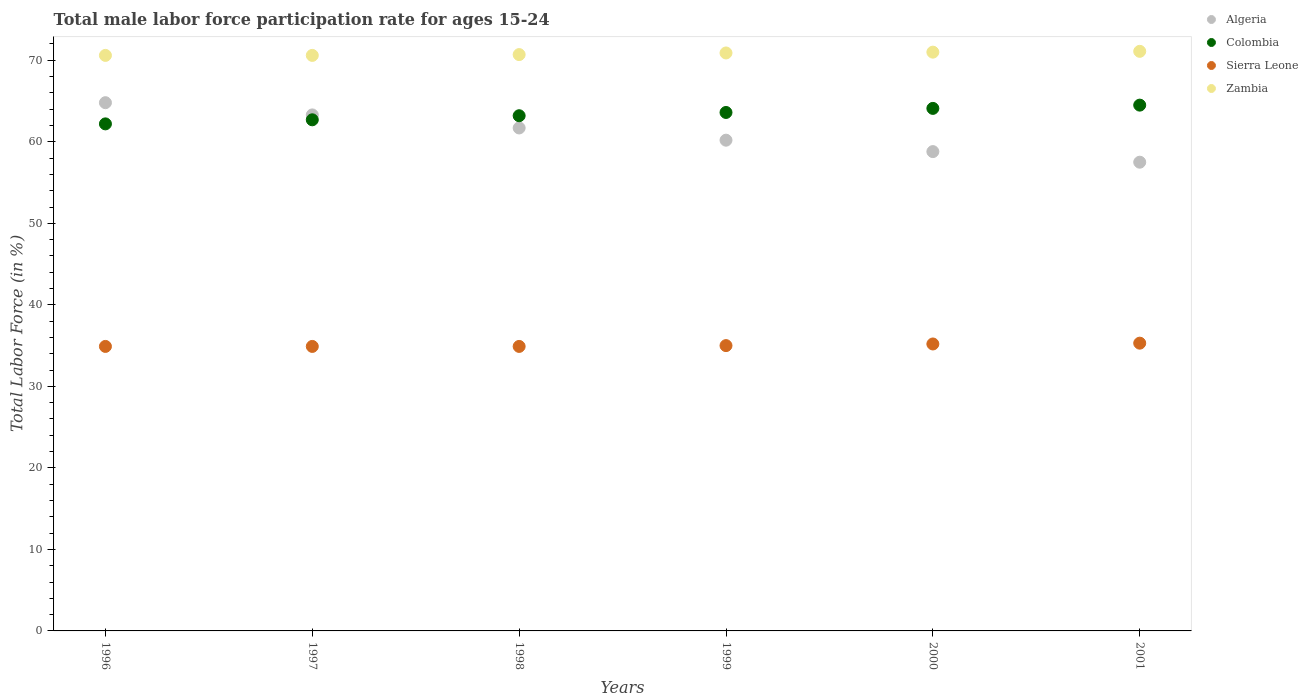How many different coloured dotlines are there?
Ensure brevity in your answer.  4. Is the number of dotlines equal to the number of legend labels?
Provide a short and direct response. Yes. What is the male labor force participation rate in Sierra Leone in 1999?
Ensure brevity in your answer.  35. Across all years, what is the maximum male labor force participation rate in Sierra Leone?
Offer a terse response. 35.3. Across all years, what is the minimum male labor force participation rate in Sierra Leone?
Your answer should be very brief. 34.9. In which year was the male labor force participation rate in Sierra Leone minimum?
Your answer should be compact. 1996. What is the total male labor force participation rate in Colombia in the graph?
Your answer should be very brief. 380.3. What is the difference between the male labor force participation rate in Zambia in 1998 and that in 1999?
Provide a short and direct response. -0.2. What is the difference between the male labor force participation rate in Colombia in 2000 and the male labor force participation rate in Algeria in 1996?
Provide a short and direct response. -0.7. What is the average male labor force participation rate in Sierra Leone per year?
Offer a very short reply. 35.03. In the year 2000, what is the difference between the male labor force participation rate in Colombia and male labor force participation rate in Zambia?
Make the answer very short. -6.9. In how many years, is the male labor force participation rate in Algeria greater than 16 %?
Offer a very short reply. 6. What is the ratio of the male labor force participation rate in Colombia in 1999 to that in 2001?
Offer a terse response. 0.99. Is the male labor force participation rate in Zambia in 1998 less than that in 2000?
Provide a short and direct response. Yes. What is the difference between the highest and the second highest male labor force participation rate in Algeria?
Your answer should be very brief. 1.5. What is the difference between the highest and the lowest male labor force participation rate in Sierra Leone?
Your answer should be compact. 0.4. In how many years, is the male labor force participation rate in Zambia greater than the average male labor force participation rate in Zambia taken over all years?
Offer a terse response. 3. Is the sum of the male labor force participation rate in Algeria in 1996 and 1997 greater than the maximum male labor force participation rate in Colombia across all years?
Your answer should be very brief. Yes. Is it the case that in every year, the sum of the male labor force participation rate in Sierra Leone and male labor force participation rate in Zambia  is greater than the sum of male labor force participation rate in Colombia and male labor force participation rate in Algeria?
Give a very brief answer. No. Is the male labor force participation rate in Colombia strictly greater than the male labor force participation rate in Zambia over the years?
Make the answer very short. No. Is the male labor force participation rate in Colombia strictly less than the male labor force participation rate in Zambia over the years?
Provide a succinct answer. Yes. How many years are there in the graph?
Give a very brief answer. 6. What is the difference between two consecutive major ticks on the Y-axis?
Make the answer very short. 10. Does the graph contain grids?
Provide a succinct answer. No. How many legend labels are there?
Make the answer very short. 4. How are the legend labels stacked?
Provide a short and direct response. Vertical. What is the title of the graph?
Give a very brief answer. Total male labor force participation rate for ages 15-24. What is the label or title of the X-axis?
Offer a terse response. Years. What is the Total Labor Force (in %) of Algeria in 1996?
Make the answer very short. 64.8. What is the Total Labor Force (in %) of Colombia in 1996?
Your answer should be very brief. 62.2. What is the Total Labor Force (in %) of Sierra Leone in 1996?
Provide a short and direct response. 34.9. What is the Total Labor Force (in %) in Zambia in 1996?
Keep it short and to the point. 70.6. What is the Total Labor Force (in %) of Algeria in 1997?
Give a very brief answer. 63.3. What is the Total Labor Force (in %) in Colombia in 1997?
Offer a very short reply. 62.7. What is the Total Labor Force (in %) of Sierra Leone in 1997?
Ensure brevity in your answer.  34.9. What is the Total Labor Force (in %) of Zambia in 1997?
Provide a succinct answer. 70.6. What is the Total Labor Force (in %) in Algeria in 1998?
Offer a very short reply. 61.7. What is the Total Labor Force (in %) of Colombia in 1998?
Give a very brief answer. 63.2. What is the Total Labor Force (in %) of Sierra Leone in 1998?
Offer a very short reply. 34.9. What is the Total Labor Force (in %) in Zambia in 1998?
Provide a succinct answer. 70.7. What is the Total Labor Force (in %) in Algeria in 1999?
Make the answer very short. 60.2. What is the Total Labor Force (in %) in Colombia in 1999?
Your answer should be compact. 63.6. What is the Total Labor Force (in %) in Zambia in 1999?
Give a very brief answer. 70.9. What is the Total Labor Force (in %) of Algeria in 2000?
Offer a very short reply. 58.8. What is the Total Labor Force (in %) of Colombia in 2000?
Offer a terse response. 64.1. What is the Total Labor Force (in %) in Sierra Leone in 2000?
Your answer should be compact. 35.2. What is the Total Labor Force (in %) of Algeria in 2001?
Offer a very short reply. 57.5. What is the Total Labor Force (in %) in Colombia in 2001?
Provide a succinct answer. 64.5. What is the Total Labor Force (in %) in Sierra Leone in 2001?
Provide a short and direct response. 35.3. What is the Total Labor Force (in %) of Zambia in 2001?
Give a very brief answer. 71.1. Across all years, what is the maximum Total Labor Force (in %) of Algeria?
Provide a short and direct response. 64.8. Across all years, what is the maximum Total Labor Force (in %) of Colombia?
Keep it short and to the point. 64.5. Across all years, what is the maximum Total Labor Force (in %) in Sierra Leone?
Offer a terse response. 35.3. Across all years, what is the maximum Total Labor Force (in %) in Zambia?
Ensure brevity in your answer.  71.1. Across all years, what is the minimum Total Labor Force (in %) in Algeria?
Your response must be concise. 57.5. Across all years, what is the minimum Total Labor Force (in %) of Colombia?
Offer a very short reply. 62.2. Across all years, what is the minimum Total Labor Force (in %) in Sierra Leone?
Give a very brief answer. 34.9. Across all years, what is the minimum Total Labor Force (in %) of Zambia?
Your answer should be very brief. 70.6. What is the total Total Labor Force (in %) of Algeria in the graph?
Provide a short and direct response. 366.3. What is the total Total Labor Force (in %) in Colombia in the graph?
Give a very brief answer. 380.3. What is the total Total Labor Force (in %) in Sierra Leone in the graph?
Offer a very short reply. 210.2. What is the total Total Labor Force (in %) in Zambia in the graph?
Provide a short and direct response. 424.9. What is the difference between the Total Labor Force (in %) of Algeria in 1996 and that in 1997?
Your response must be concise. 1.5. What is the difference between the Total Labor Force (in %) of Algeria in 1996 and that in 1998?
Your answer should be very brief. 3.1. What is the difference between the Total Labor Force (in %) in Sierra Leone in 1996 and that in 1998?
Offer a very short reply. 0. What is the difference between the Total Labor Force (in %) in Zambia in 1996 and that in 1998?
Your response must be concise. -0.1. What is the difference between the Total Labor Force (in %) of Algeria in 1996 and that in 1999?
Keep it short and to the point. 4.6. What is the difference between the Total Labor Force (in %) in Colombia in 1996 and that in 1999?
Make the answer very short. -1.4. What is the difference between the Total Labor Force (in %) in Sierra Leone in 1996 and that in 1999?
Give a very brief answer. -0.1. What is the difference between the Total Labor Force (in %) of Algeria in 1996 and that in 2000?
Provide a succinct answer. 6. What is the difference between the Total Labor Force (in %) of Sierra Leone in 1996 and that in 2000?
Your response must be concise. -0.3. What is the difference between the Total Labor Force (in %) of Zambia in 1996 and that in 2000?
Give a very brief answer. -0.4. What is the difference between the Total Labor Force (in %) in Algeria in 1996 and that in 2001?
Provide a succinct answer. 7.3. What is the difference between the Total Labor Force (in %) of Sierra Leone in 1996 and that in 2001?
Your answer should be compact. -0.4. What is the difference between the Total Labor Force (in %) in Zambia in 1996 and that in 2001?
Offer a terse response. -0.5. What is the difference between the Total Labor Force (in %) in Algeria in 1997 and that in 1998?
Provide a short and direct response. 1.6. What is the difference between the Total Labor Force (in %) of Zambia in 1997 and that in 1998?
Provide a short and direct response. -0.1. What is the difference between the Total Labor Force (in %) in Algeria in 1997 and that in 2000?
Ensure brevity in your answer.  4.5. What is the difference between the Total Labor Force (in %) in Colombia in 1997 and that in 2000?
Your answer should be compact. -1.4. What is the difference between the Total Labor Force (in %) of Sierra Leone in 1997 and that in 2000?
Your response must be concise. -0.3. What is the difference between the Total Labor Force (in %) in Zambia in 1997 and that in 2000?
Make the answer very short. -0.4. What is the difference between the Total Labor Force (in %) of Algeria in 1997 and that in 2001?
Give a very brief answer. 5.8. What is the difference between the Total Labor Force (in %) of Colombia in 1997 and that in 2001?
Offer a terse response. -1.8. What is the difference between the Total Labor Force (in %) of Sierra Leone in 1997 and that in 2001?
Provide a short and direct response. -0.4. What is the difference between the Total Labor Force (in %) in Zambia in 1997 and that in 2001?
Offer a very short reply. -0.5. What is the difference between the Total Labor Force (in %) of Sierra Leone in 1998 and that in 1999?
Give a very brief answer. -0.1. What is the difference between the Total Labor Force (in %) of Zambia in 1998 and that in 1999?
Offer a very short reply. -0.2. What is the difference between the Total Labor Force (in %) of Colombia in 1998 and that in 2000?
Ensure brevity in your answer.  -0.9. What is the difference between the Total Labor Force (in %) of Sierra Leone in 1998 and that in 2000?
Offer a terse response. -0.3. What is the difference between the Total Labor Force (in %) of Zambia in 1998 and that in 2001?
Provide a short and direct response. -0.4. What is the difference between the Total Labor Force (in %) of Zambia in 1999 and that in 2000?
Provide a succinct answer. -0.1. What is the difference between the Total Labor Force (in %) of Colombia in 1999 and that in 2001?
Offer a very short reply. -0.9. What is the difference between the Total Labor Force (in %) of Algeria in 2000 and that in 2001?
Offer a very short reply. 1.3. What is the difference between the Total Labor Force (in %) in Colombia in 2000 and that in 2001?
Provide a short and direct response. -0.4. What is the difference between the Total Labor Force (in %) of Sierra Leone in 2000 and that in 2001?
Provide a short and direct response. -0.1. What is the difference between the Total Labor Force (in %) of Algeria in 1996 and the Total Labor Force (in %) of Sierra Leone in 1997?
Your answer should be compact. 29.9. What is the difference between the Total Labor Force (in %) in Colombia in 1996 and the Total Labor Force (in %) in Sierra Leone in 1997?
Ensure brevity in your answer.  27.3. What is the difference between the Total Labor Force (in %) in Colombia in 1996 and the Total Labor Force (in %) in Zambia in 1997?
Offer a very short reply. -8.4. What is the difference between the Total Labor Force (in %) in Sierra Leone in 1996 and the Total Labor Force (in %) in Zambia in 1997?
Make the answer very short. -35.7. What is the difference between the Total Labor Force (in %) of Algeria in 1996 and the Total Labor Force (in %) of Sierra Leone in 1998?
Keep it short and to the point. 29.9. What is the difference between the Total Labor Force (in %) in Colombia in 1996 and the Total Labor Force (in %) in Sierra Leone in 1998?
Offer a very short reply. 27.3. What is the difference between the Total Labor Force (in %) of Sierra Leone in 1996 and the Total Labor Force (in %) of Zambia in 1998?
Keep it short and to the point. -35.8. What is the difference between the Total Labor Force (in %) in Algeria in 1996 and the Total Labor Force (in %) in Sierra Leone in 1999?
Give a very brief answer. 29.8. What is the difference between the Total Labor Force (in %) in Algeria in 1996 and the Total Labor Force (in %) in Zambia in 1999?
Your response must be concise. -6.1. What is the difference between the Total Labor Force (in %) of Colombia in 1996 and the Total Labor Force (in %) of Sierra Leone in 1999?
Offer a terse response. 27.2. What is the difference between the Total Labor Force (in %) of Colombia in 1996 and the Total Labor Force (in %) of Zambia in 1999?
Your response must be concise. -8.7. What is the difference between the Total Labor Force (in %) in Sierra Leone in 1996 and the Total Labor Force (in %) in Zambia in 1999?
Provide a short and direct response. -36. What is the difference between the Total Labor Force (in %) of Algeria in 1996 and the Total Labor Force (in %) of Colombia in 2000?
Give a very brief answer. 0.7. What is the difference between the Total Labor Force (in %) in Algeria in 1996 and the Total Labor Force (in %) in Sierra Leone in 2000?
Your answer should be very brief. 29.6. What is the difference between the Total Labor Force (in %) in Sierra Leone in 1996 and the Total Labor Force (in %) in Zambia in 2000?
Offer a very short reply. -36.1. What is the difference between the Total Labor Force (in %) of Algeria in 1996 and the Total Labor Force (in %) of Sierra Leone in 2001?
Give a very brief answer. 29.5. What is the difference between the Total Labor Force (in %) of Colombia in 1996 and the Total Labor Force (in %) of Sierra Leone in 2001?
Your response must be concise. 26.9. What is the difference between the Total Labor Force (in %) of Sierra Leone in 1996 and the Total Labor Force (in %) of Zambia in 2001?
Offer a very short reply. -36.2. What is the difference between the Total Labor Force (in %) in Algeria in 1997 and the Total Labor Force (in %) in Colombia in 1998?
Your answer should be compact. 0.1. What is the difference between the Total Labor Force (in %) in Algeria in 1997 and the Total Labor Force (in %) in Sierra Leone in 1998?
Keep it short and to the point. 28.4. What is the difference between the Total Labor Force (in %) of Algeria in 1997 and the Total Labor Force (in %) of Zambia in 1998?
Offer a terse response. -7.4. What is the difference between the Total Labor Force (in %) of Colombia in 1997 and the Total Labor Force (in %) of Sierra Leone in 1998?
Your answer should be compact. 27.8. What is the difference between the Total Labor Force (in %) of Colombia in 1997 and the Total Labor Force (in %) of Zambia in 1998?
Make the answer very short. -8. What is the difference between the Total Labor Force (in %) in Sierra Leone in 1997 and the Total Labor Force (in %) in Zambia in 1998?
Provide a short and direct response. -35.8. What is the difference between the Total Labor Force (in %) in Algeria in 1997 and the Total Labor Force (in %) in Sierra Leone in 1999?
Give a very brief answer. 28.3. What is the difference between the Total Labor Force (in %) of Algeria in 1997 and the Total Labor Force (in %) of Zambia in 1999?
Ensure brevity in your answer.  -7.6. What is the difference between the Total Labor Force (in %) of Colombia in 1997 and the Total Labor Force (in %) of Sierra Leone in 1999?
Your answer should be very brief. 27.7. What is the difference between the Total Labor Force (in %) of Sierra Leone in 1997 and the Total Labor Force (in %) of Zambia in 1999?
Make the answer very short. -36. What is the difference between the Total Labor Force (in %) of Algeria in 1997 and the Total Labor Force (in %) of Colombia in 2000?
Make the answer very short. -0.8. What is the difference between the Total Labor Force (in %) of Algeria in 1997 and the Total Labor Force (in %) of Sierra Leone in 2000?
Offer a very short reply. 28.1. What is the difference between the Total Labor Force (in %) in Colombia in 1997 and the Total Labor Force (in %) in Sierra Leone in 2000?
Give a very brief answer. 27.5. What is the difference between the Total Labor Force (in %) in Colombia in 1997 and the Total Labor Force (in %) in Zambia in 2000?
Offer a terse response. -8.3. What is the difference between the Total Labor Force (in %) in Sierra Leone in 1997 and the Total Labor Force (in %) in Zambia in 2000?
Make the answer very short. -36.1. What is the difference between the Total Labor Force (in %) in Algeria in 1997 and the Total Labor Force (in %) in Colombia in 2001?
Offer a very short reply. -1.2. What is the difference between the Total Labor Force (in %) of Algeria in 1997 and the Total Labor Force (in %) of Sierra Leone in 2001?
Ensure brevity in your answer.  28. What is the difference between the Total Labor Force (in %) of Algeria in 1997 and the Total Labor Force (in %) of Zambia in 2001?
Provide a succinct answer. -7.8. What is the difference between the Total Labor Force (in %) of Colombia in 1997 and the Total Labor Force (in %) of Sierra Leone in 2001?
Offer a terse response. 27.4. What is the difference between the Total Labor Force (in %) in Sierra Leone in 1997 and the Total Labor Force (in %) in Zambia in 2001?
Your answer should be very brief. -36.2. What is the difference between the Total Labor Force (in %) of Algeria in 1998 and the Total Labor Force (in %) of Colombia in 1999?
Give a very brief answer. -1.9. What is the difference between the Total Labor Force (in %) in Algeria in 1998 and the Total Labor Force (in %) in Sierra Leone in 1999?
Keep it short and to the point. 26.7. What is the difference between the Total Labor Force (in %) in Algeria in 1998 and the Total Labor Force (in %) in Zambia in 1999?
Provide a short and direct response. -9.2. What is the difference between the Total Labor Force (in %) of Colombia in 1998 and the Total Labor Force (in %) of Sierra Leone in 1999?
Provide a succinct answer. 28.2. What is the difference between the Total Labor Force (in %) of Sierra Leone in 1998 and the Total Labor Force (in %) of Zambia in 1999?
Ensure brevity in your answer.  -36. What is the difference between the Total Labor Force (in %) of Algeria in 1998 and the Total Labor Force (in %) of Colombia in 2000?
Your answer should be very brief. -2.4. What is the difference between the Total Labor Force (in %) in Algeria in 1998 and the Total Labor Force (in %) in Sierra Leone in 2000?
Make the answer very short. 26.5. What is the difference between the Total Labor Force (in %) of Algeria in 1998 and the Total Labor Force (in %) of Zambia in 2000?
Your response must be concise. -9.3. What is the difference between the Total Labor Force (in %) of Colombia in 1998 and the Total Labor Force (in %) of Zambia in 2000?
Offer a terse response. -7.8. What is the difference between the Total Labor Force (in %) of Sierra Leone in 1998 and the Total Labor Force (in %) of Zambia in 2000?
Keep it short and to the point. -36.1. What is the difference between the Total Labor Force (in %) of Algeria in 1998 and the Total Labor Force (in %) of Colombia in 2001?
Offer a terse response. -2.8. What is the difference between the Total Labor Force (in %) in Algeria in 1998 and the Total Labor Force (in %) in Sierra Leone in 2001?
Provide a short and direct response. 26.4. What is the difference between the Total Labor Force (in %) of Algeria in 1998 and the Total Labor Force (in %) of Zambia in 2001?
Make the answer very short. -9.4. What is the difference between the Total Labor Force (in %) in Colombia in 1998 and the Total Labor Force (in %) in Sierra Leone in 2001?
Offer a terse response. 27.9. What is the difference between the Total Labor Force (in %) of Sierra Leone in 1998 and the Total Labor Force (in %) of Zambia in 2001?
Ensure brevity in your answer.  -36.2. What is the difference between the Total Labor Force (in %) in Algeria in 1999 and the Total Labor Force (in %) in Zambia in 2000?
Give a very brief answer. -10.8. What is the difference between the Total Labor Force (in %) of Colombia in 1999 and the Total Labor Force (in %) of Sierra Leone in 2000?
Your answer should be very brief. 28.4. What is the difference between the Total Labor Force (in %) in Colombia in 1999 and the Total Labor Force (in %) in Zambia in 2000?
Offer a terse response. -7.4. What is the difference between the Total Labor Force (in %) in Sierra Leone in 1999 and the Total Labor Force (in %) in Zambia in 2000?
Ensure brevity in your answer.  -36. What is the difference between the Total Labor Force (in %) of Algeria in 1999 and the Total Labor Force (in %) of Colombia in 2001?
Ensure brevity in your answer.  -4.3. What is the difference between the Total Labor Force (in %) in Algeria in 1999 and the Total Labor Force (in %) in Sierra Leone in 2001?
Keep it short and to the point. 24.9. What is the difference between the Total Labor Force (in %) in Colombia in 1999 and the Total Labor Force (in %) in Sierra Leone in 2001?
Keep it short and to the point. 28.3. What is the difference between the Total Labor Force (in %) of Sierra Leone in 1999 and the Total Labor Force (in %) of Zambia in 2001?
Provide a short and direct response. -36.1. What is the difference between the Total Labor Force (in %) in Colombia in 2000 and the Total Labor Force (in %) in Sierra Leone in 2001?
Make the answer very short. 28.8. What is the difference between the Total Labor Force (in %) of Sierra Leone in 2000 and the Total Labor Force (in %) of Zambia in 2001?
Provide a short and direct response. -35.9. What is the average Total Labor Force (in %) in Algeria per year?
Ensure brevity in your answer.  61.05. What is the average Total Labor Force (in %) of Colombia per year?
Your answer should be compact. 63.38. What is the average Total Labor Force (in %) of Sierra Leone per year?
Provide a succinct answer. 35.03. What is the average Total Labor Force (in %) in Zambia per year?
Keep it short and to the point. 70.82. In the year 1996, what is the difference between the Total Labor Force (in %) in Algeria and Total Labor Force (in %) in Sierra Leone?
Provide a short and direct response. 29.9. In the year 1996, what is the difference between the Total Labor Force (in %) in Colombia and Total Labor Force (in %) in Sierra Leone?
Your answer should be compact. 27.3. In the year 1996, what is the difference between the Total Labor Force (in %) of Sierra Leone and Total Labor Force (in %) of Zambia?
Provide a succinct answer. -35.7. In the year 1997, what is the difference between the Total Labor Force (in %) of Algeria and Total Labor Force (in %) of Colombia?
Your answer should be compact. 0.6. In the year 1997, what is the difference between the Total Labor Force (in %) in Algeria and Total Labor Force (in %) in Sierra Leone?
Offer a terse response. 28.4. In the year 1997, what is the difference between the Total Labor Force (in %) of Algeria and Total Labor Force (in %) of Zambia?
Your answer should be very brief. -7.3. In the year 1997, what is the difference between the Total Labor Force (in %) of Colombia and Total Labor Force (in %) of Sierra Leone?
Your answer should be very brief. 27.8. In the year 1997, what is the difference between the Total Labor Force (in %) in Colombia and Total Labor Force (in %) in Zambia?
Provide a succinct answer. -7.9. In the year 1997, what is the difference between the Total Labor Force (in %) of Sierra Leone and Total Labor Force (in %) of Zambia?
Make the answer very short. -35.7. In the year 1998, what is the difference between the Total Labor Force (in %) of Algeria and Total Labor Force (in %) of Sierra Leone?
Provide a short and direct response. 26.8. In the year 1998, what is the difference between the Total Labor Force (in %) of Algeria and Total Labor Force (in %) of Zambia?
Your answer should be very brief. -9. In the year 1998, what is the difference between the Total Labor Force (in %) in Colombia and Total Labor Force (in %) in Sierra Leone?
Provide a succinct answer. 28.3. In the year 1998, what is the difference between the Total Labor Force (in %) in Colombia and Total Labor Force (in %) in Zambia?
Provide a succinct answer. -7.5. In the year 1998, what is the difference between the Total Labor Force (in %) in Sierra Leone and Total Labor Force (in %) in Zambia?
Your answer should be compact. -35.8. In the year 1999, what is the difference between the Total Labor Force (in %) of Algeria and Total Labor Force (in %) of Sierra Leone?
Give a very brief answer. 25.2. In the year 1999, what is the difference between the Total Labor Force (in %) of Colombia and Total Labor Force (in %) of Sierra Leone?
Provide a succinct answer. 28.6. In the year 1999, what is the difference between the Total Labor Force (in %) in Colombia and Total Labor Force (in %) in Zambia?
Make the answer very short. -7.3. In the year 1999, what is the difference between the Total Labor Force (in %) of Sierra Leone and Total Labor Force (in %) of Zambia?
Your answer should be very brief. -35.9. In the year 2000, what is the difference between the Total Labor Force (in %) of Algeria and Total Labor Force (in %) of Colombia?
Give a very brief answer. -5.3. In the year 2000, what is the difference between the Total Labor Force (in %) of Algeria and Total Labor Force (in %) of Sierra Leone?
Ensure brevity in your answer.  23.6. In the year 2000, what is the difference between the Total Labor Force (in %) in Colombia and Total Labor Force (in %) in Sierra Leone?
Make the answer very short. 28.9. In the year 2000, what is the difference between the Total Labor Force (in %) in Sierra Leone and Total Labor Force (in %) in Zambia?
Your response must be concise. -35.8. In the year 2001, what is the difference between the Total Labor Force (in %) of Algeria and Total Labor Force (in %) of Colombia?
Keep it short and to the point. -7. In the year 2001, what is the difference between the Total Labor Force (in %) in Algeria and Total Labor Force (in %) in Sierra Leone?
Offer a very short reply. 22.2. In the year 2001, what is the difference between the Total Labor Force (in %) in Colombia and Total Labor Force (in %) in Sierra Leone?
Make the answer very short. 29.2. In the year 2001, what is the difference between the Total Labor Force (in %) in Sierra Leone and Total Labor Force (in %) in Zambia?
Keep it short and to the point. -35.8. What is the ratio of the Total Labor Force (in %) of Algeria in 1996 to that in 1997?
Give a very brief answer. 1.02. What is the ratio of the Total Labor Force (in %) of Colombia in 1996 to that in 1997?
Provide a succinct answer. 0.99. What is the ratio of the Total Labor Force (in %) in Sierra Leone in 1996 to that in 1997?
Your response must be concise. 1. What is the ratio of the Total Labor Force (in %) in Algeria in 1996 to that in 1998?
Your answer should be very brief. 1.05. What is the ratio of the Total Labor Force (in %) in Colombia in 1996 to that in 1998?
Give a very brief answer. 0.98. What is the ratio of the Total Labor Force (in %) in Zambia in 1996 to that in 1998?
Ensure brevity in your answer.  1. What is the ratio of the Total Labor Force (in %) in Algeria in 1996 to that in 1999?
Ensure brevity in your answer.  1.08. What is the ratio of the Total Labor Force (in %) of Sierra Leone in 1996 to that in 1999?
Provide a succinct answer. 1. What is the ratio of the Total Labor Force (in %) in Zambia in 1996 to that in 1999?
Keep it short and to the point. 1. What is the ratio of the Total Labor Force (in %) of Algeria in 1996 to that in 2000?
Your answer should be compact. 1.1. What is the ratio of the Total Labor Force (in %) in Colombia in 1996 to that in 2000?
Provide a short and direct response. 0.97. What is the ratio of the Total Labor Force (in %) in Zambia in 1996 to that in 2000?
Offer a terse response. 0.99. What is the ratio of the Total Labor Force (in %) of Algeria in 1996 to that in 2001?
Your answer should be compact. 1.13. What is the ratio of the Total Labor Force (in %) of Colombia in 1996 to that in 2001?
Make the answer very short. 0.96. What is the ratio of the Total Labor Force (in %) of Sierra Leone in 1996 to that in 2001?
Provide a short and direct response. 0.99. What is the ratio of the Total Labor Force (in %) in Algeria in 1997 to that in 1998?
Offer a very short reply. 1.03. What is the ratio of the Total Labor Force (in %) in Colombia in 1997 to that in 1998?
Your answer should be very brief. 0.99. What is the ratio of the Total Labor Force (in %) of Sierra Leone in 1997 to that in 1998?
Your answer should be very brief. 1. What is the ratio of the Total Labor Force (in %) in Zambia in 1997 to that in 1998?
Your response must be concise. 1. What is the ratio of the Total Labor Force (in %) in Algeria in 1997 to that in 1999?
Ensure brevity in your answer.  1.05. What is the ratio of the Total Labor Force (in %) of Colombia in 1997 to that in 1999?
Give a very brief answer. 0.99. What is the ratio of the Total Labor Force (in %) in Algeria in 1997 to that in 2000?
Give a very brief answer. 1.08. What is the ratio of the Total Labor Force (in %) of Colombia in 1997 to that in 2000?
Keep it short and to the point. 0.98. What is the ratio of the Total Labor Force (in %) of Zambia in 1997 to that in 2000?
Make the answer very short. 0.99. What is the ratio of the Total Labor Force (in %) of Algeria in 1997 to that in 2001?
Offer a very short reply. 1.1. What is the ratio of the Total Labor Force (in %) in Colombia in 1997 to that in 2001?
Provide a short and direct response. 0.97. What is the ratio of the Total Labor Force (in %) of Sierra Leone in 1997 to that in 2001?
Provide a short and direct response. 0.99. What is the ratio of the Total Labor Force (in %) of Algeria in 1998 to that in 1999?
Make the answer very short. 1.02. What is the ratio of the Total Labor Force (in %) of Colombia in 1998 to that in 1999?
Give a very brief answer. 0.99. What is the ratio of the Total Labor Force (in %) of Sierra Leone in 1998 to that in 1999?
Your response must be concise. 1. What is the ratio of the Total Labor Force (in %) in Zambia in 1998 to that in 1999?
Your answer should be compact. 1. What is the ratio of the Total Labor Force (in %) of Algeria in 1998 to that in 2000?
Your answer should be compact. 1.05. What is the ratio of the Total Labor Force (in %) in Colombia in 1998 to that in 2000?
Offer a terse response. 0.99. What is the ratio of the Total Labor Force (in %) in Sierra Leone in 1998 to that in 2000?
Your response must be concise. 0.99. What is the ratio of the Total Labor Force (in %) of Algeria in 1998 to that in 2001?
Give a very brief answer. 1.07. What is the ratio of the Total Labor Force (in %) in Colombia in 1998 to that in 2001?
Offer a very short reply. 0.98. What is the ratio of the Total Labor Force (in %) of Sierra Leone in 1998 to that in 2001?
Give a very brief answer. 0.99. What is the ratio of the Total Labor Force (in %) in Zambia in 1998 to that in 2001?
Your response must be concise. 0.99. What is the ratio of the Total Labor Force (in %) of Algeria in 1999 to that in 2000?
Offer a terse response. 1.02. What is the ratio of the Total Labor Force (in %) in Colombia in 1999 to that in 2000?
Provide a short and direct response. 0.99. What is the ratio of the Total Labor Force (in %) of Sierra Leone in 1999 to that in 2000?
Keep it short and to the point. 0.99. What is the ratio of the Total Labor Force (in %) of Algeria in 1999 to that in 2001?
Give a very brief answer. 1.05. What is the ratio of the Total Labor Force (in %) of Algeria in 2000 to that in 2001?
Your answer should be compact. 1.02. What is the ratio of the Total Labor Force (in %) in Sierra Leone in 2000 to that in 2001?
Your response must be concise. 1. What is the difference between the highest and the second highest Total Labor Force (in %) of Algeria?
Keep it short and to the point. 1.5. What is the difference between the highest and the second highest Total Labor Force (in %) of Sierra Leone?
Your answer should be compact. 0.1. What is the difference between the highest and the second highest Total Labor Force (in %) in Zambia?
Offer a very short reply. 0.1. What is the difference between the highest and the lowest Total Labor Force (in %) of Algeria?
Your answer should be compact. 7.3. What is the difference between the highest and the lowest Total Labor Force (in %) of Colombia?
Provide a short and direct response. 2.3. What is the difference between the highest and the lowest Total Labor Force (in %) in Zambia?
Provide a succinct answer. 0.5. 